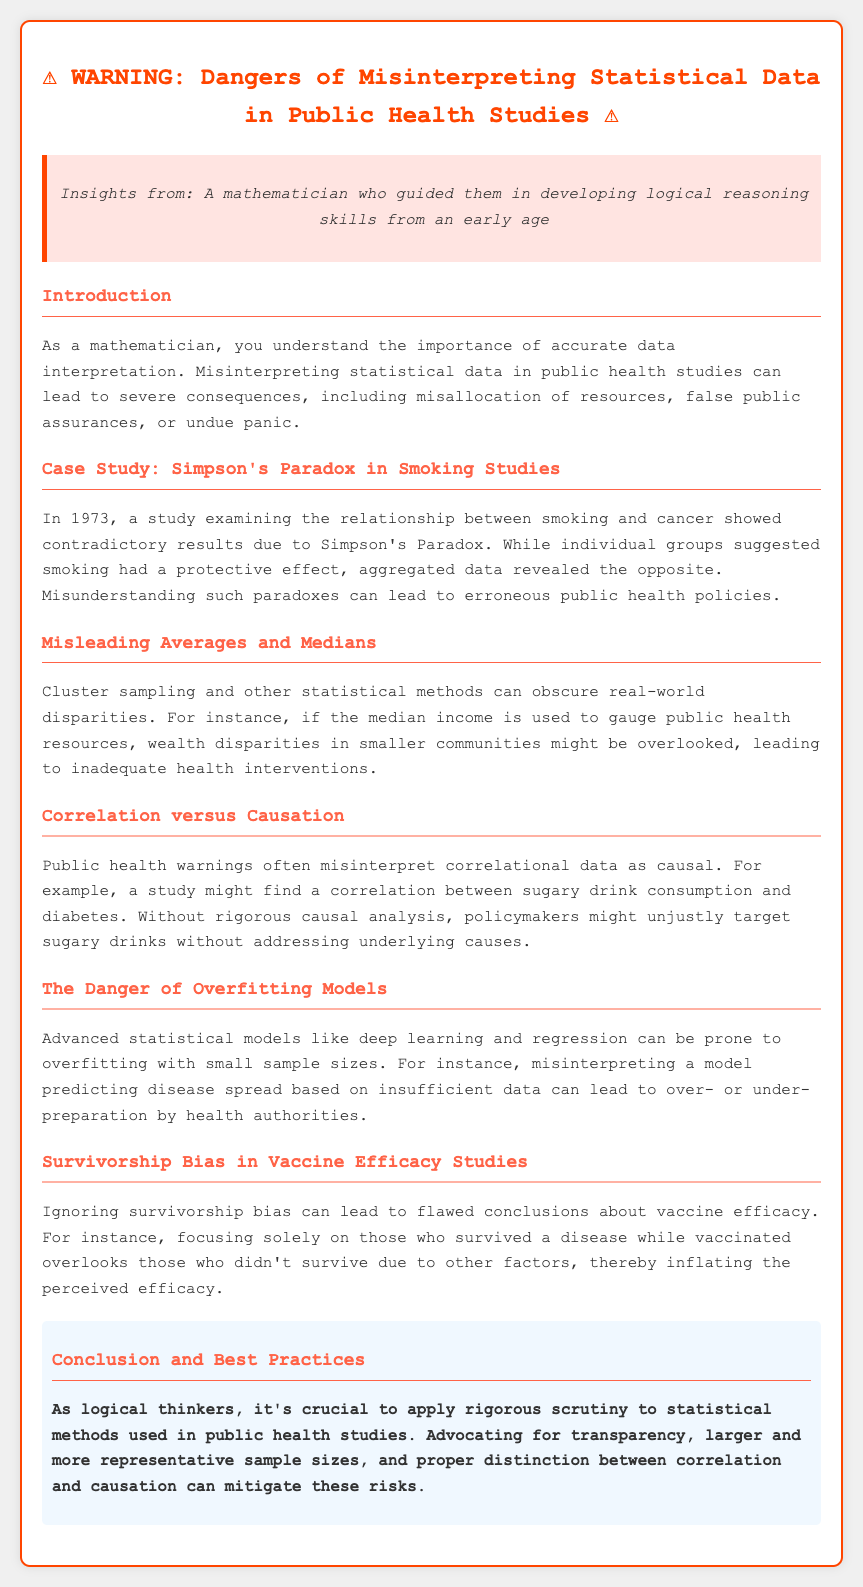What is the title of the warning document? The title of the document is presented prominently at the top of the rendered page.
Answer: Warning: Statistical Data Misinterpretation in Public Health When was the case study about Simpson's Paradox published? The case study mentioned in the document refers specifically to an event in 1973.
Answer: 1973 What dangerous misunderstanding does the document highlight in correlation versus causation? The document explains that public health warnings often misinterpret correlational data as causal, impacting policy.
Answer: Correlational data as causal What is one consequence of using misleading averages in public health resources? The document details how using median income can overlook real-world disparities in health interventions.
Answer: Inadequate health interventions What type of bias does the document say can inflate perceived vaccine efficacy? The document specifically mentions survivorship bias as a factor that can lead to flawed conclusions about vaccine effectiveness.
Answer: Survivorship bias What is emphasized as a best practice to mitigate risks in statistical methods? The document concludes by advocating for specific practices to improve statistical scrutiny in public health studies.
Answer: Transparency What statistical issues can arise from advanced models with small sample sizes? The document addresses the danger of overfitting models when utilizing small data samples.
Answer: Overfitting models What is the color of the warning box in the document? The document specifies the background color of the warning box that encapsulates the warning message.
Answer: #ffe4e1 